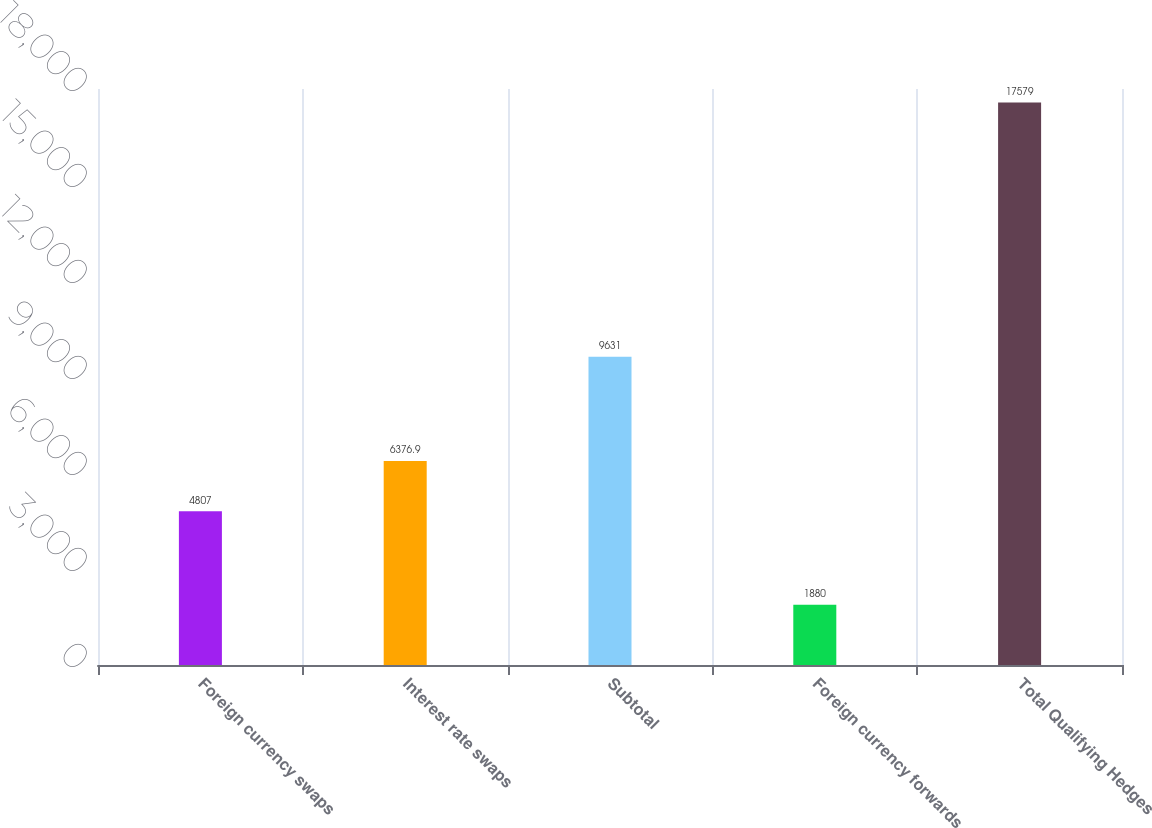Convert chart to OTSL. <chart><loc_0><loc_0><loc_500><loc_500><bar_chart><fcel>Foreign currency swaps<fcel>Interest rate swaps<fcel>Subtotal<fcel>Foreign currency forwards<fcel>Total Qualifying Hedges<nl><fcel>4807<fcel>6376.9<fcel>9631<fcel>1880<fcel>17579<nl></chart> 